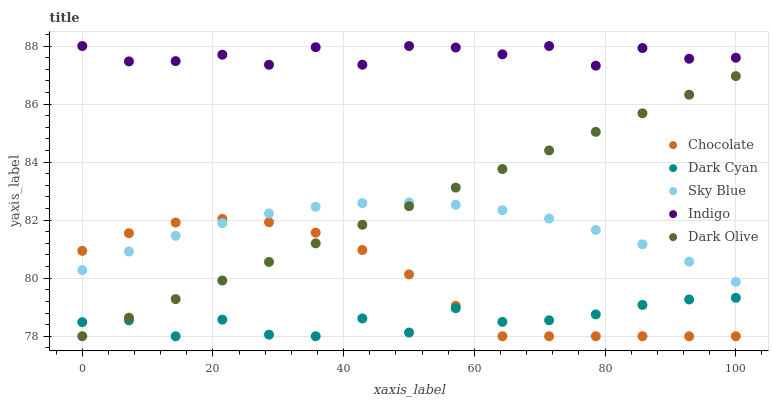Does Dark Cyan have the minimum area under the curve?
Answer yes or no. Yes. Does Indigo have the maximum area under the curve?
Answer yes or no. Yes. Does Sky Blue have the minimum area under the curve?
Answer yes or no. No. Does Sky Blue have the maximum area under the curve?
Answer yes or no. No. Is Dark Olive the smoothest?
Answer yes or no. Yes. Is Indigo the roughest?
Answer yes or no. Yes. Is Sky Blue the smoothest?
Answer yes or no. No. Is Sky Blue the roughest?
Answer yes or no. No. Does Dark Cyan have the lowest value?
Answer yes or no. Yes. Does Sky Blue have the lowest value?
Answer yes or no. No. Does Indigo have the highest value?
Answer yes or no. Yes. Does Sky Blue have the highest value?
Answer yes or no. No. Is Sky Blue less than Indigo?
Answer yes or no. Yes. Is Sky Blue greater than Dark Cyan?
Answer yes or no. Yes. Does Chocolate intersect Dark Cyan?
Answer yes or no. Yes. Is Chocolate less than Dark Cyan?
Answer yes or no. No. Is Chocolate greater than Dark Cyan?
Answer yes or no. No. Does Sky Blue intersect Indigo?
Answer yes or no. No. 